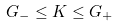Convert formula to latex. <formula><loc_0><loc_0><loc_500><loc_500>G _ { - } \leq K \leq G _ { + }</formula> 